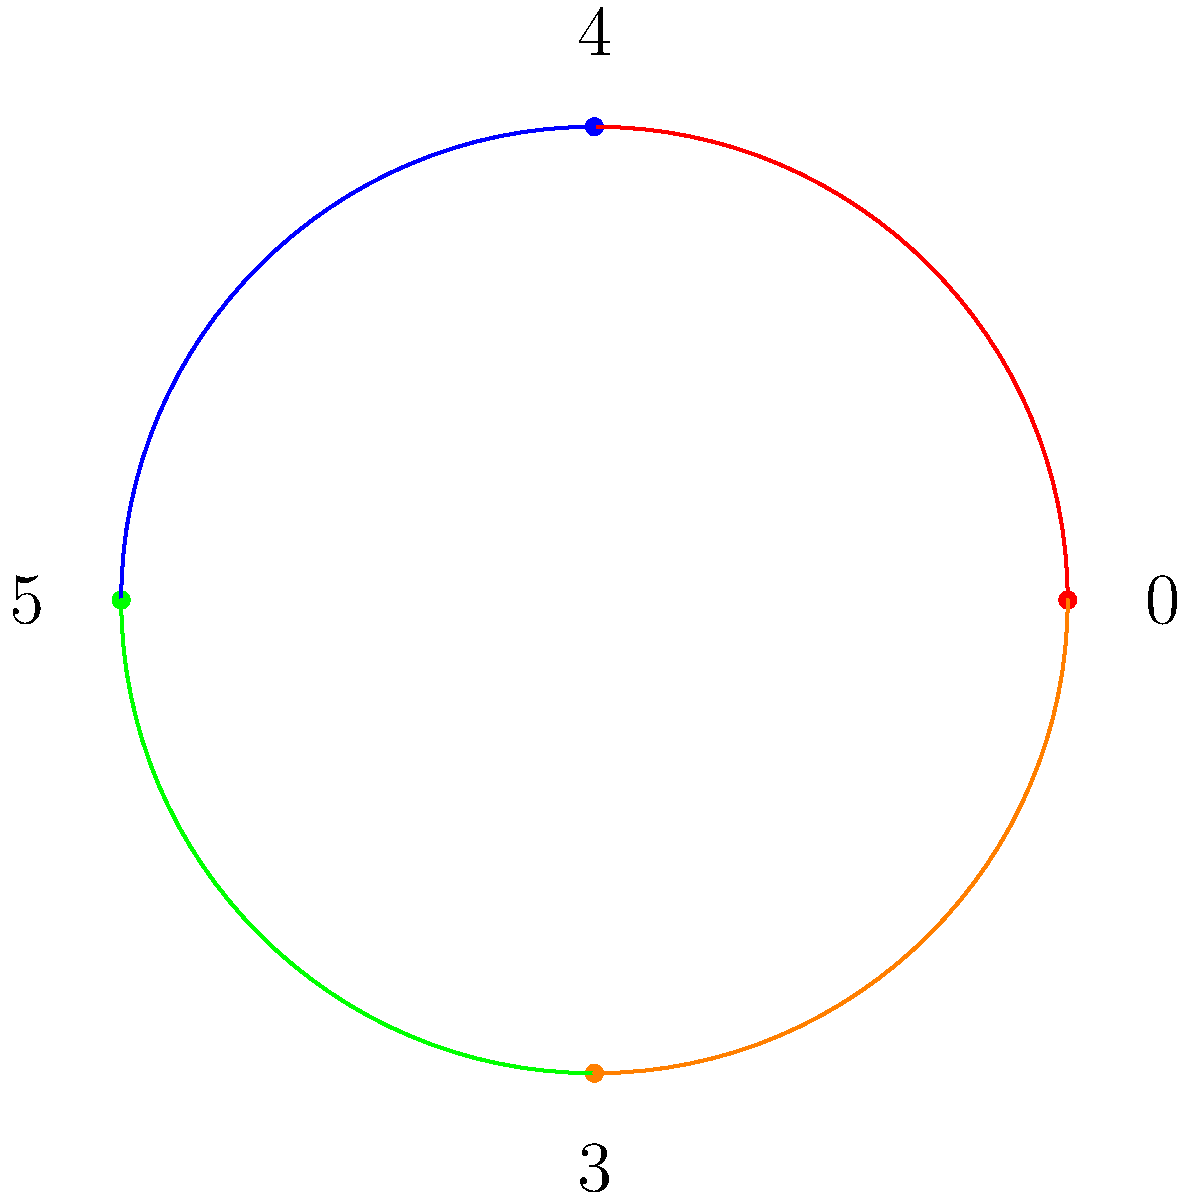In Travis Tritt's hit song "T-R-O-U-B-L-E," the main chord progression follows a cyclic pattern. If we represent the chords as elements of a cyclic group $C_4$, where $0$ represents C, $1$ represents C#, $2$ represents D, and so on, which element would complete the cycle after applying the group operation three times to the initial chord? To solve this problem, let's follow these steps:

1) First, we need to identify the chord progression in the song. "T-R-O-U-B-L-E" typically follows a C-E-F-D progression.

2) We can represent this progression in our cyclic group $C_4$ as follows:
   C = 0
   E = 4
   F = 5
   D = 2

3) In cyclic group notation, we can write this as: $(0, 4, 5, 2)$

4) The group operation in $C_4$ is addition modulo 4. This means we add the elements and then take the result modulo 4.

5) Let's apply the group operation three times:
   - First application: $(0+4) \mod 4 = 0$
   - Second application: $(0+5) \mod 4 = 1$
   - Third application: $(1+2) \mod 4 = 3$

6) Therefore, after applying the group operation three times, we end up at element 3.

7) In our musical representation, 3 corresponds to D#/Eb.

Thus, the element that completes the cycle after applying the group operation three times is 3, which represents D#/Eb in our musical context.
Answer: 3 (D#/Eb) 